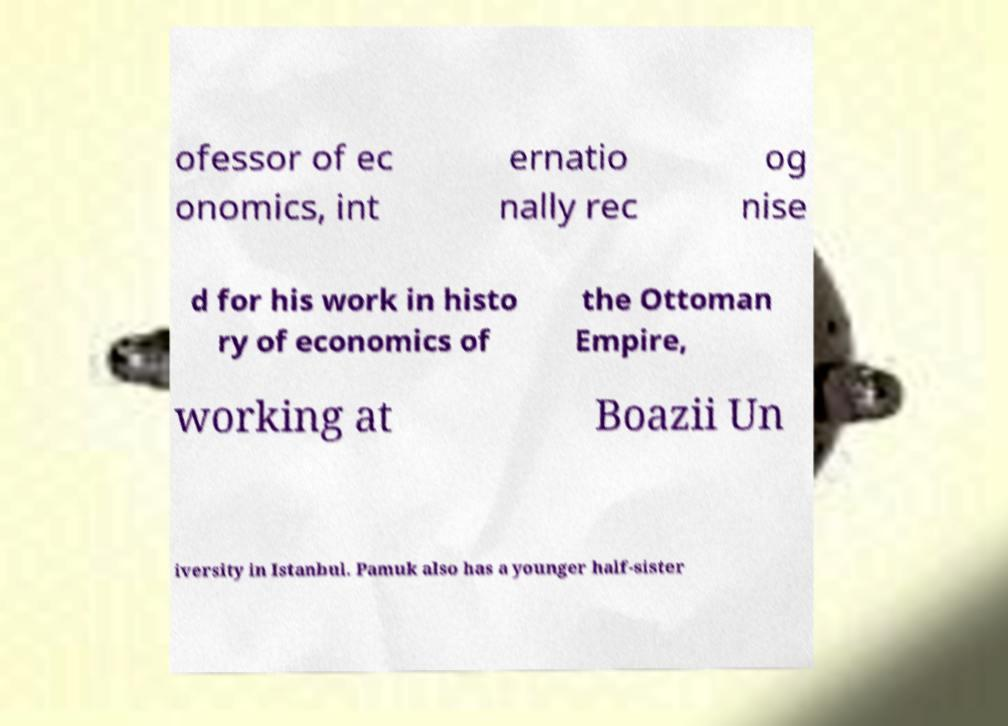Could you assist in decoding the text presented in this image and type it out clearly? ofessor of ec onomics, int ernatio nally rec og nise d for his work in histo ry of economics of the Ottoman Empire, working at Boazii Un iversity in Istanbul. Pamuk also has a younger half-sister 